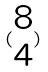Convert formula to latex. <formula><loc_0><loc_0><loc_500><loc_500>( \begin{matrix} 8 \\ 4 \end{matrix} )</formula> 